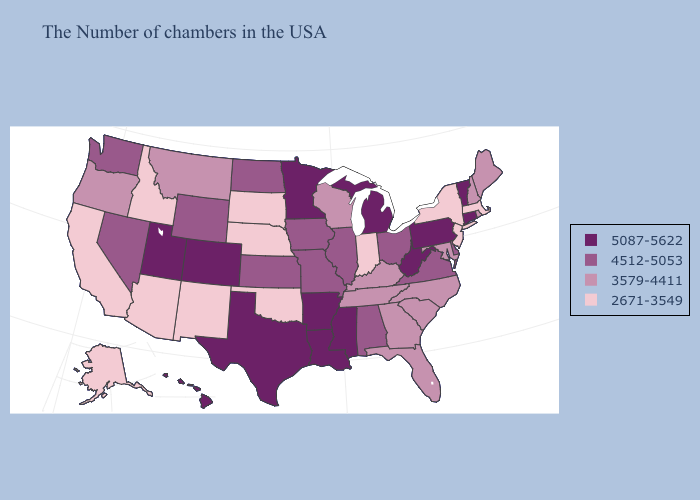Among the states that border North Carolina , which have the highest value?
Give a very brief answer. Virginia. Among the states that border Florida , which have the highest value?
Short answer required. Alabama. Name the states that have a value in the range 5087-5622?
Keep it brief. Vermont, Connecticut, Pennsylvania, West Virginia, Michigan, Mississippi, Louisiana, Arkansas, Minnesota, Texas, Colorado, Utah, Hawaii. Does Maine have the highest value in the USA?
Give a very brief answer. No. Among the states that border Montana , which have the lowest value?
Short answer required. South Dakota, Idaho. What is the value of Massachusetts?
Keep it brief. 2671-3549. Name the states that have a value in the range 3579-4411?
Give a very brief answer. Maine, Rhode Island, New Hampshire, Maryland, North Carolina, South Carolina, Florida, Georgia, Kentucky, Tennessee, Wisconsin, Montana, Oregon. Does Georgia have the lowest value in the USA?
Keep it brief. No. Name the states that have a value in the range 5087-5622?
Quick response, please. Vermont, Connecticut, Pennsylvania, West Virginia, Michigan, Mississippi, Louisiana, Arkansas, Minnesota, Texas, Colorado, Utah, Hawaii. Does the map have missing data?
Give a very brief answer. No. Is the legend a continuous bar?
Be succinct. No. Name the states that have a value in the range 3579-4411?
Write a very short answer. Maine, Rhode Island, New Hampshire, Maryland, North Carolina, South Carolina, Florida, Georgia, Kentucky, Tennessee, Wisconsin, Montana, Oregon. Does Delaware have a lower value than New Mexico?
Quick response, please. No. What is the value of Virginia?
Keep it brief. 4512-5053. What is the value of Hawaii?
Keep it brief. 5087-5622. 